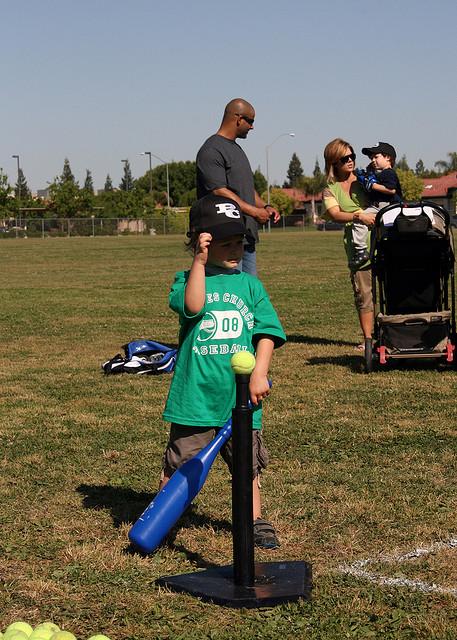What is this child about to do with the baseball?
Quick response, please. Hit it. What color is the boy's hat?
Write a very short answer. Black. What is the ball sitting on?
Answer briefly. Tee. Is the man playing with the children related?
Quick response, please. No. What color are the tennis balls?
Concise answer only. Yellow. What is the approximate age of the child?
Short answer required. 6. Does the dirt look walked on?
Answer briefly. Yes. What toy character is on the boy's shirt?
Answer briefly. None. What object is the little boy holding?
Write a very short answer. Bat. What is the little boy in the middle holding?
Short answer required. Bat. What does the man's shirt say?
Quick response, please. 08. What is that bat made out of?
Be succinct. Plastic. 